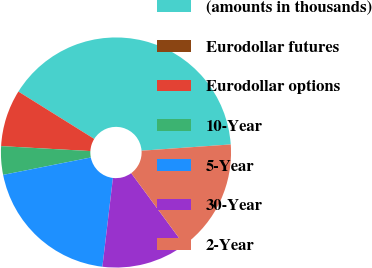<chart> <loc_0><loc_0><loc_500><loc_500><pie_chart><fcel>(amounts in thousands)<fcel>Eurodollar futures<fcel>Eurodollar options<fcel>10-Year<fcel>5-Year<fcel>30-Year<fcel>2-Year<nl><fcel>40.0%<fcel>0.0%<fcel>8.0%<fcel>4.0%<fcel>20.0%<fcel>12.0%<fcel>16.0%<nl></chart> 